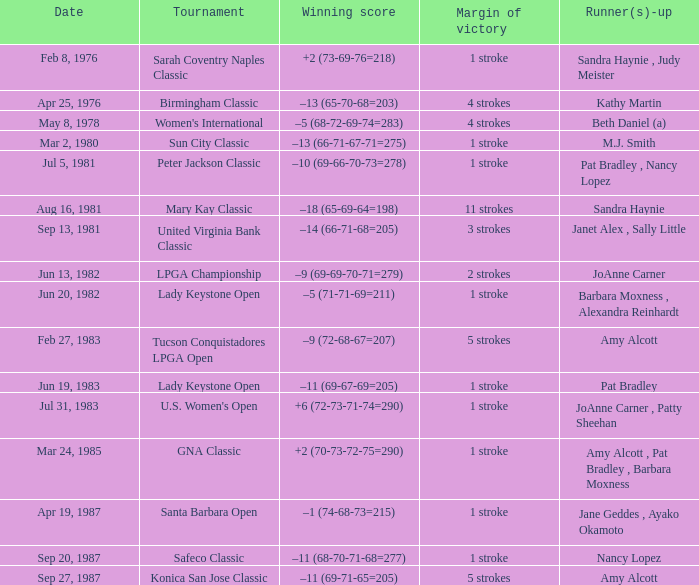What is the contest in which the triumphant score is -9 (69-69-70-71=279)? LPGA Championship. 